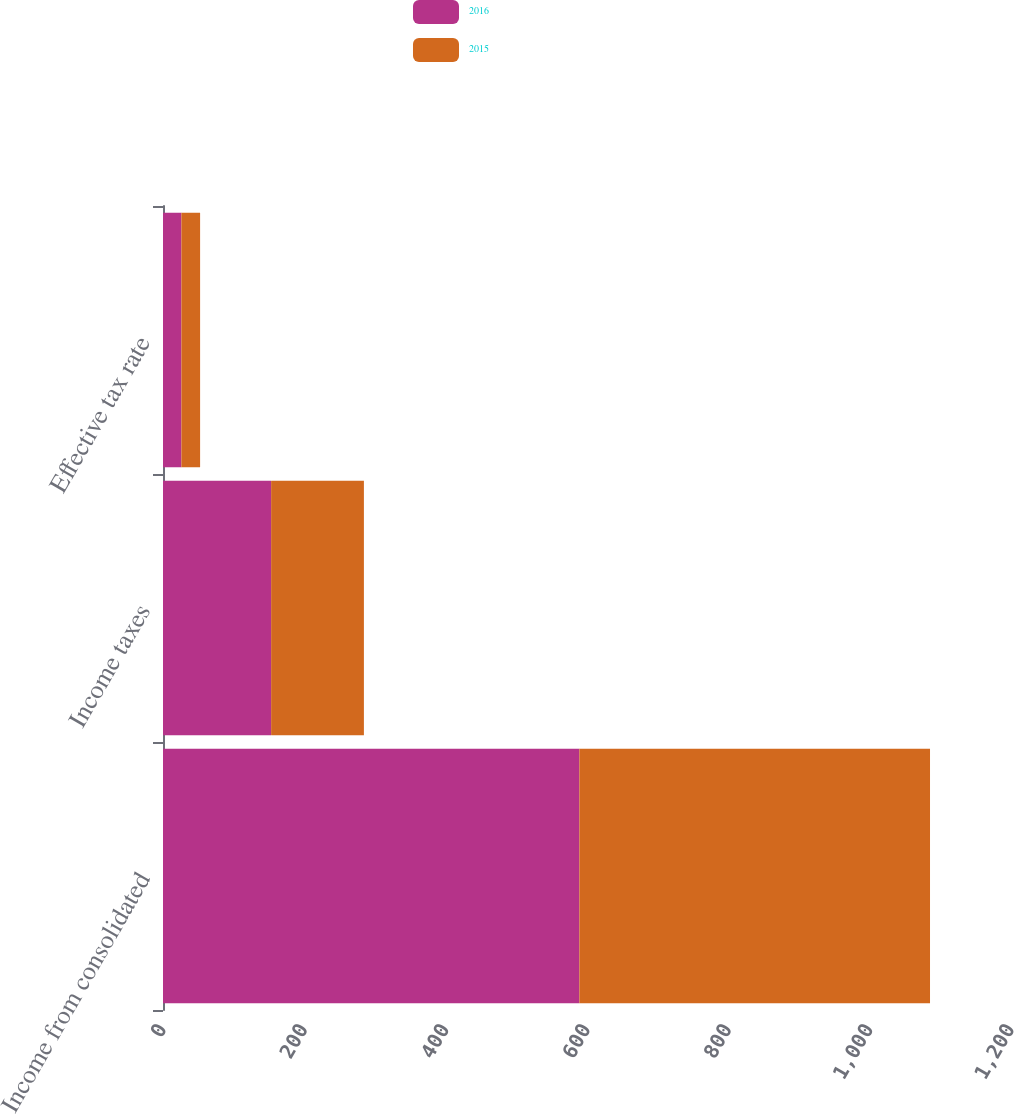<chart> <loc_0><loc_0><loc_500><loc_500><stacked_bar_chart><ecel><fcel>Income from consolidated<fcel>Income taxes<fcel>Effective tax rate<nl><fcel>2016<fcel>589.2<fcel>153<fcel>26<nl><fcel>2015<fcel>496.2<fcel>131.3<fcel>26.5<nl></chart> 